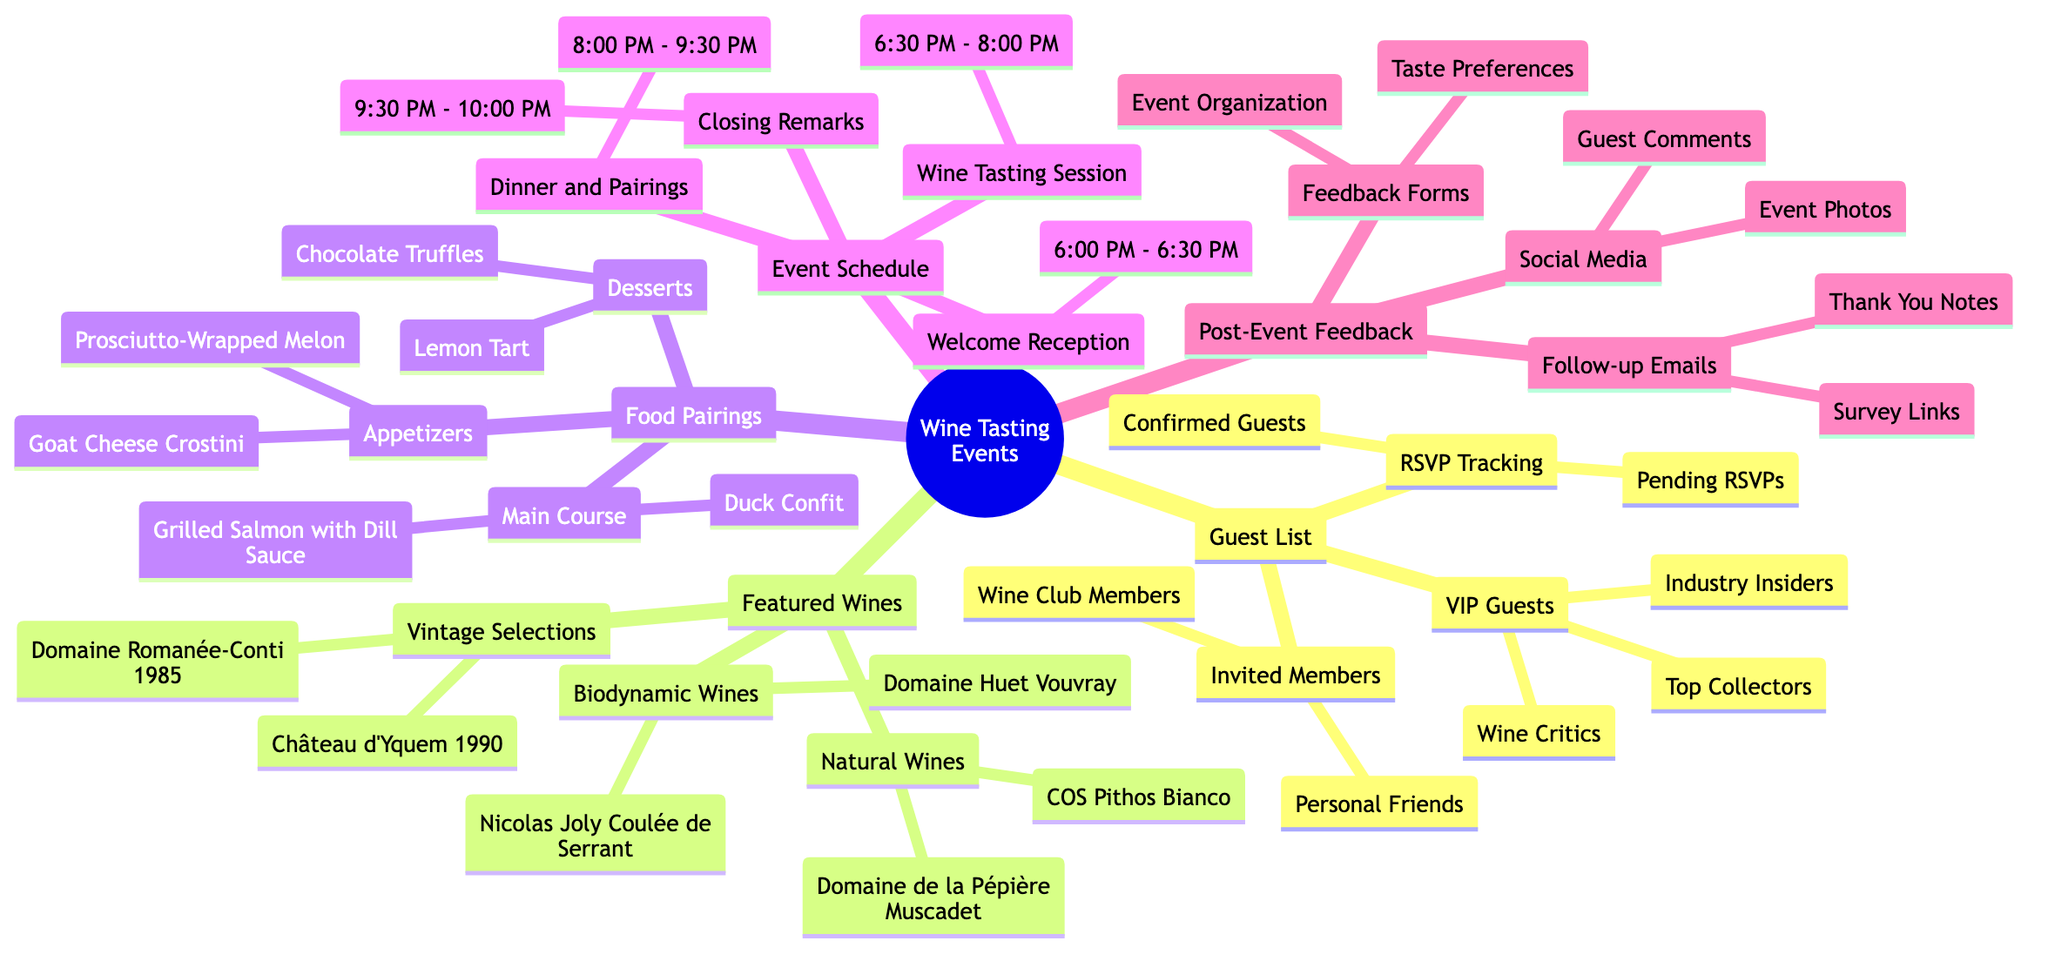What are the two categories of VIP guests listed? The diagram identifies "Wine Critics" and "Industry Insiders" as two categories of VIP guests under the "Guest List" section.
Answer: Wine Critics, Industry Insiders How long does the wine tasting session last? The diagram shows the "Wine Tasting Session" is scheduled from "6:30 PM" to "8:00 PM," indicating it lasts for one hour and thirty minutes.
Answer: 1 hour 30 minutes Name one featured biodynamic wine. From the "Featured Wines" section, "Domaine Huet Vouvray" is listed as one of the biodynamic wines.
Answer: Domaine Huet Vouvray What type of dessert is included in the food pairings? The food pairings section lists "Desserts," and specifically mentions "Chocolate Truffles" as one type, hence confirming it's included in the pairings.
Answer: Chocolate Truffles How many different categories are there under Featured Wines? The "Featured Wines" section contains three distinct categories: "Natural Wines," "Biodynamic Wines," and "Vintage Selections," totaling three categories.
Answer: 3 What actions are included in Post-Event Feedback? The "Post-Event Feedback" section includes "Feedback Forms," "Follow-up Emails," and "Social Media." Each of these actions is crucial for gathering insights after the event.
Answer: Feedback Forms, Follow-up Emails, Social Media Which course is served between 8:00 PM and 9:30 PM? The "Dinner and Pairings" event is scheduled from "8:00 PM" to "9:30 PM," meaning that this course is explicitly served during this timeframe.
Answer: Dinner and Pairings How many types of appetizers are listed? Under the "Food Pairings" section, there are two types specifically mentioned in the "Appetizers" category: "Goat Cheese Crostini" and "Prosciutto-Wrapped Melon," totaling two types.
Answer: 2 